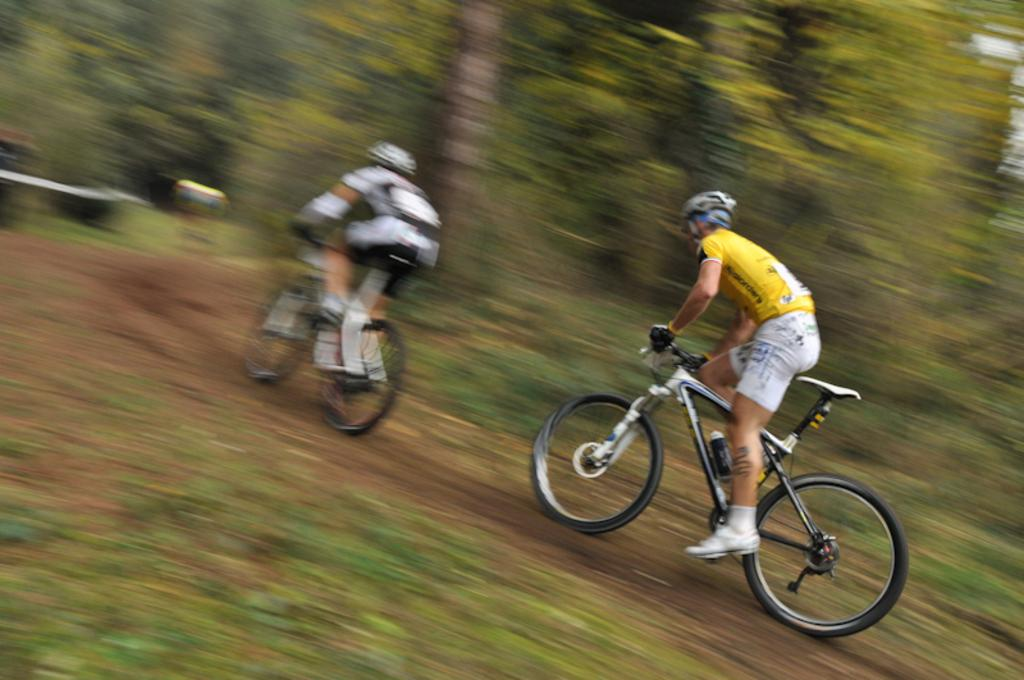What type of vegetation can be seen in the image? There is grass in the image. What are the two people in the image doing? They are riding bicycles in the image. What is visible beneath the grass and bicycles? The ground is visible in the image. What can be seen in the distance behind the grass and bicycles? There are trees in the background of the image. How would you describe the appearance of the background? The background appears blurry in the image. What type of root can be seen growing through the lace on the board in the image? There is no root, lace, or board present in the image. 